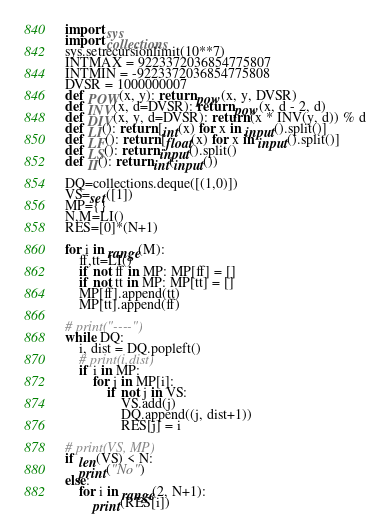<code> <loc_0><loc_0><loc_500><loc_500><_Python_>import sys
import collections
sys.setrecursionlimit(10**7)
INTMAX = 9223372036854775807
INTMIN = -9223372036854775808
DVSR = 1000000007
def POW(x, y): return pow(x, y, DVSR)
def INV(x, d=DVSR): return pow(x, d - 2, d)
def DIV(x, y, d=DVSR): return (x * INV(y, d)) % d
def LI(): return [int(x) for x in input().split()]
def LF(): return [float(x) for x in input().split()]
def LS(): return input().split()
def II(): return int(input())

DQ=collections.deque([(1,0)])
VS=set([1])
MP={}
N,M=LI()
RES=[0]*(N+1)

for i in range(M):
    ff,tt=LI()
    if not ff in MP: MP[ff] = []
    if not tt in MP: MP[tt] = []
    MP[ff].append(tt)
    MP[tt].append(ff)

# print("----")
while DQ:
    i, dist = DQ.popleft()
    # print(i,dist)
    if i in MP:
        for j in MP[i]:
            if not j in VS:
                VS.add(j)
                DQ.append((j, dist+1))
                RES[j] = i

# print(VS, MP)
if len(VS) < N:
    print("No")
else:
    for i in range(2, N+1):
        print(RES[i])
</code> 